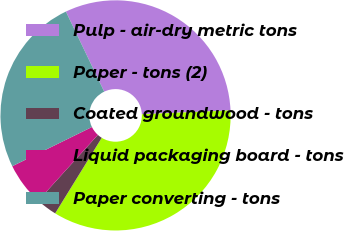Convert chart. <chart><loc_0><loc_0><loc_500><loc_500><pie_chart><fcel>Pulp - air-dry metric tons<fcel>Paper - tons (2)<fcel>Coated groundwood - tons<fcel>Liquid packaging board - tons<fcel>Paper converting - tons<nl><fcel>31.41%<fcel>34.48%<fcel>2.93%<fcel>6.0%<fcel>25.18%<nl></chart> 